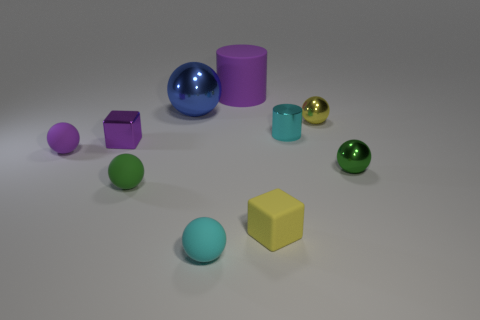Subtract 2 spheres. How many spheres are left? 4 Subtract all green balls. How many balls are left? 4 Subtract all green metallic balls. How many balls are left? 5 Subtract all yellow balls. Subtract all cyan cylinders. How many balls are left? 5 Subtract all spheres. How many objects are left? 4 Add 1 yellow matte objects. How many yellow matte objects are left? 2 Add 1 large blue spheres. How many large blue spheres exist? 2 Subtract 0 yellow cylinders. How many objects are left? 10 Subtract all small blue shiny cylinders. Subtract all small cyan matte objects. How many objects are left? 9 